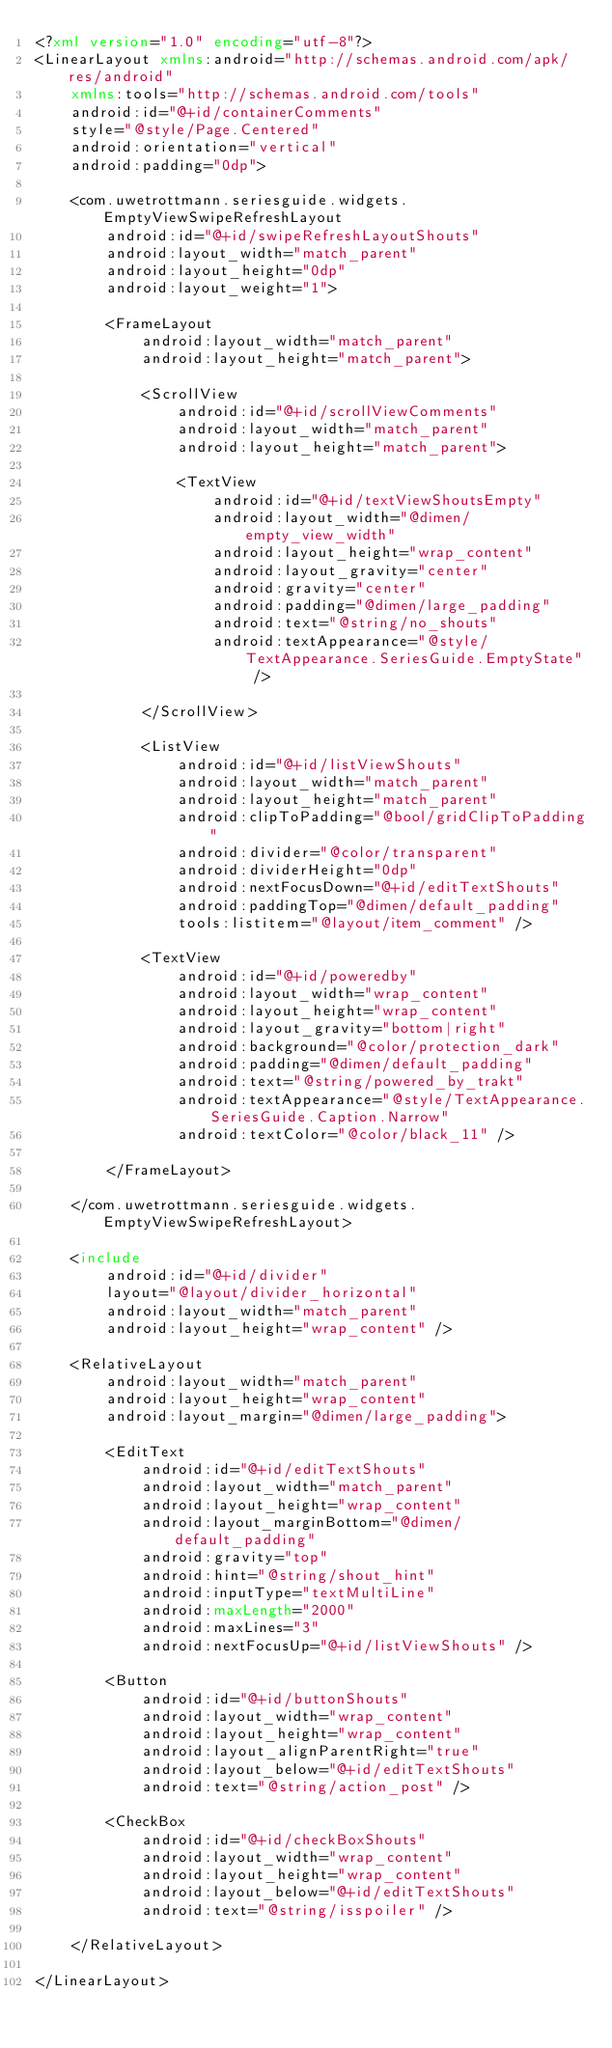<code> <loc_0><loc_0><loc_500><loc_500><_XML_><?xml version="1.0" encoding="utf-8"?>
<LinearLayout xmlns:android="http://schemas.android.com/apk/res/android"
    xmlns:tools="http://schemas.android.com/tools"
    android:id="@+id/containerComments"
    style="@style/Page.Centered"
    android:orientation="vertical"
    android:padding="0dp">

    <com.uwetrottmann.seriesguide.widgets.EmptyViewSwipeRefreshLayout
        android:id="@+id/swipeRefreshLayoutShouts"
        android:layout_width="match_parent"
        android:layout_height="0dp"
        android:layout_weight="1">

        <FrameLayout
            android:layout_width="match_parent"
            android:layout_height="match_parent">

            <ScrollView
                android:id="@+id/scrollViewComments"
                android:layout_width="match_parent"
                android:layout_height="match_parent">

                <TextView
                    android:id="@+id/textViewShoutsEmpty"
                    android:layout_width="@dimen/empty_view_width"
                    android:layout_height="wrap_content"
                    android:layout_gravity="center"
                    android:gravity="center"
                    android:padding="@dimen/large_padding"
                    android:text="@string/no_shouts"
                    android:textAppearance="@style/TextAppearance.SeriesGuide.EmptyState" />

            </ScrollView>

            <ListView
                android:id="@+id/listViewShouts"
                android:layout_width="match_parent"
                android:layout_height="match_parent"
                android:clipToPadding="@bool/gridClipToPadding"
                android:divider="@color/transparent"
                android:dividerHeight="0dp"
                android:nextFocusDown="@+id/editTextShouts"
                android:paddingTop="@dimen/default_padding"
                tools:listitem="@layout/item_comment" />

            <TextView
                android:id="@+id/poweredby"
                android:layout_width="wrap_content"
                android:layout_height="wrap_content"
                android:layout_gravity="bottom|right"
                android:background="@color/protection_dark"
                android:padding="@dimen/default_padding"
                android:text="@string/powered_by_trakt"
                android:textAppearance="@style/TextAppearance.SeriesGuide.Caption.Narrow"
                android:textColor="@color/black_11" />

        </FrameLayout>

    </com.uwetrottmann.seriesguide.widgets.EmptyViewSwipeRefreshLayout>

    <include
        android:id="@+id/divider"
        layout="@layout/divider_horizontal"
        android:layout_width="match_parent"
        android:layout_height="wrap_content" />

    <RelativeLayout
        android:layout_width="match_parent"
        android:layout_height="wrap_content"
        android:layout_margin="@dimen/large_padding">

        <EditText
            android:id="@+id/editTextShouts"
            android:layout_width="match_parent"
            android:layout_height="wrap_content"
            android:layout_marginBottom="@dimen/default_padding"
            android:gravity="top"
            android:hint="@string/shout_hint"
            android:inputType="textMultiLine"
            android:maxLength="2000"
            android:maxLines="3"
            android:nextFocusUp="@+id/listViewShouts" />

        <Button
            android:id="@+id/buttonShouts"
            android:layout_width="wrap_content"
            android:layout_height="wrap_content"
            android:layout_alignParentRight="true"
            android:layout_below="@+id/editTextShouts"
            android:text="@string/action_post" />

        <CheckBox
            android:id="@+id/checkBoxShouts"
            android:layout_width="wrap_content"
            android:layout_height="wrap_content"
            android:layout_below="@+id/editTextShouts"
            android:text="@string/isspoiler" />

    </RelativeLayout>

</LinearLayout>
</code> 